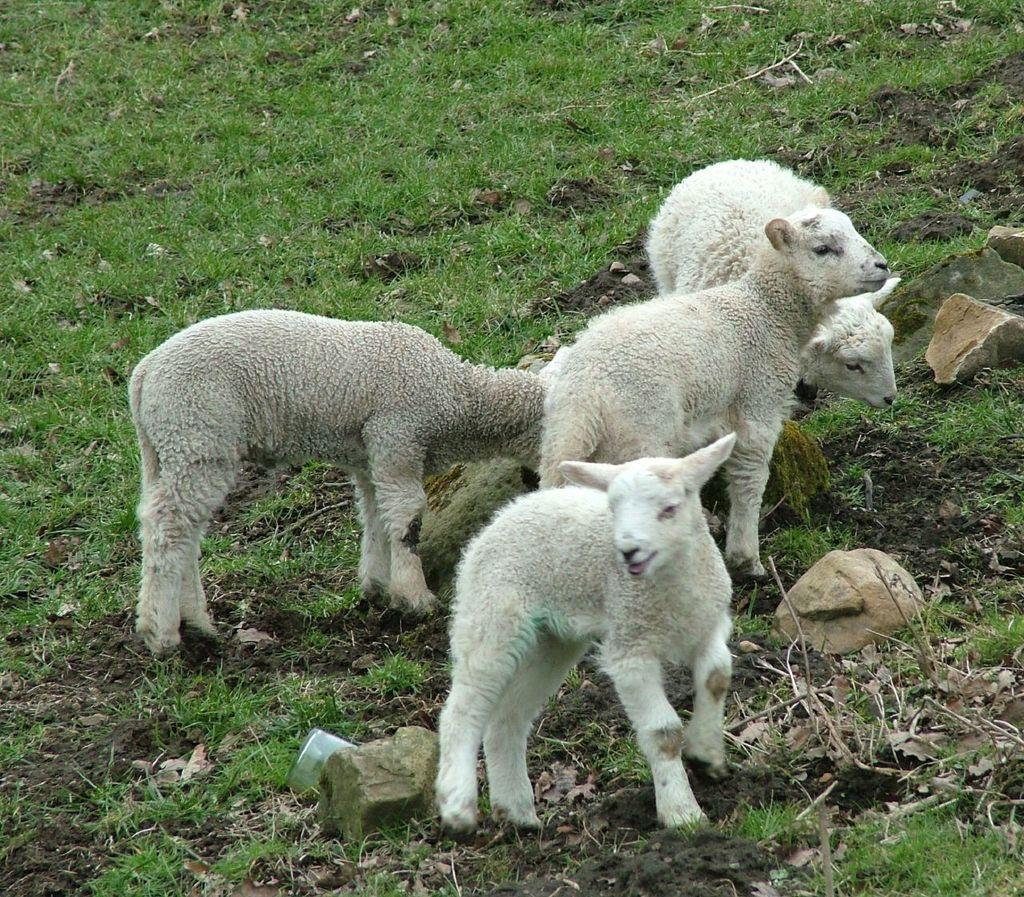How many lambs are present in the image? There are four lambs in the image. What is the surface on which the lambs are standing? The lambs are standing on grass. What can be seen on the right side of the image? There are rocks on the right side of the image. Is there a scarecrow in the image? No, there is no scarecrow present in the image. 